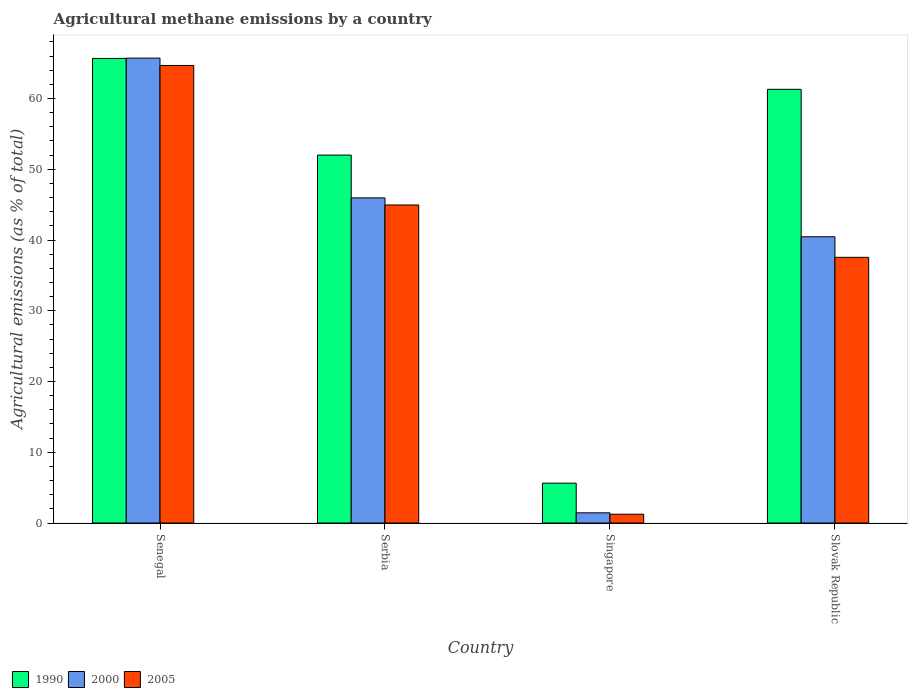How many different coloured bars are there?
Your answer should be compact. 3. Are the number of bars per tick equal to the number of legend labels?
Your response must be concise. Yes. Are the number of bars on each tick of the X-axis equal?
Your answer should be compact. Yes. What is the label of the 3rd group of bars from the left?
Give a very brief answer. Singapore. What is the amount of agricultural methane emitted in 2005 in Slovak Republic?
Give a very brief answer. 37.55. Across all countries, what is the maximum amount of agricultural methane emitted in 2000?
Offer a very short reply. 65.71. Across all countries, what is the minimum amount of agricultural methane emitted in 2000?
Keep it short and to the point. 1.44. In which country was the amount of agricultural methane emitted in 2005 maximum?
Your answer should be compact. Senegal. In which country was the amount of agricultural methane emitted in 2000 minimum?
Make the answer very short. Singapore. What is the total amount of agricultural methane emitted in 2000 in the graph?
Give a very brief answer. 153.56. What is the difference between the amount of agricultural methane emitted in 2005 in Serbia and that in Singapore?
Keep it short and to the point. 43.7. What is the difference between the amount of agricultural methane emitted in 2005 in Senegal and the amount of agricultural methane emitted in 2000 in Slovak Republic?
Ensure brevity in your answer.  24.21. What is the average amount of agricultural methane emitted in 2005 per country?
Your answer should be very brief. 37.1. What is the difference between the amount of agricultural methane emitted of/in 2005 and amount of agricultural methane emitted of/in 2000 in Singapore?
Give a very brief answer. -0.2. What is the ratio of the amount of agricultural methane emitted in 2000 in Serbia to that in Singapore?
Your answer should be compact. 31.84. What is the difference between the highest and the second highest amount of agricultural methane emitted in 1990?
Keep it short and to the point. 13.66. What is the difference between the highest and the lowest amount of agricultural methane emitted in 2000?
Your response must be concise. 64.26. Is the sum of the amount of agricultural methane emitted in 2005 in Senegal and Slovak Republic greater than the maximum amount of agricultural methane emitted in 1990 across all countries?
Make the answer very short. Yes. What does the 2nd bar from the right in Senegal represents?
Your answer should be compact. 2000. How many countries are there in the graph?
Make the answer very short. 4. Does the graph contain any zero values?
Provide a succinct answer. No. Does the graph contain grids?
Ensure brevity in your answer.  No. How are the legend labels stacked?
Ensure brevity in your answer.  Horizontal. What is the title of the graph?
Offer a very short reply. Agricultural methane emissions by a country. Does "1968" appear as one of the legend labels in the graph?
Give a very brief answer. No. What is the label or title of the X-axis?
Ensure brevity in your answer.  Country. What is the label or title of the Y-axis?
Offer a terse response. Agricultural emissions (as % of total). What is the Agricultural emissions (as % of total) in 1990 in Senegal?
Provide a short and direct response. 65.66. What is the Agricultural emissions (as % of total) of 2000 in Senegal?
Your answer should be compact. 65.71. What is the Agricultural emissions (as % of total) in 2005 in Senegal?
Provide a short and direct response. 64.67. What is the Agricultural emissions (as % of total) in 1990 in Serbia?
Keep it short and to the point. 52. What is the Agricultural emissions (as % of total) of 2000 in Serbia?
Keep it short and to the point. 45.95. What is the Agricultural emissions (as % of total) of 2005 in Serbia?
Your answer should be compact. 44.95. What is the Agricultural emissions (as % of total) of 1990 in Singapore?
Provide a short and direct response. 5.63. What is the Agricultural emissions (as % of total) in 2000 in Singapore?
Offer a terse response. 1.44. What is the Agricultural emissions (as % of total) of 2005 in Singapore?
Your answer should be very brief. 1.25. What is the Agricultural emissions (as % of total) in 1990 in Slovak Republic?
Offer a terse response. 61.3. What is the Agricultural emissions (as % of total) of 2000 in Slovak Republic?
Your response must be concise. 40.46. What is the Agricultural emissions (as % of total) in 2005 in Slovak Republic?
Provide a succinct answer. 37.55. Across all countries, what is the maximum Agricultural emissions (as % of total) in 1990?
Ensure brevity in your answer.  65.66. Across all countries, what is the maximum Agricultural emissions (as % of total) of 2000?
Provide a succinct answer. 65.71. Across all countries, what is the maximum Agricultural emissions (as % of total) in 2005?
Your answer should be very brief. 64.67. Across all countries, what is the minimum Agricultural emissions (as % of total) of 1990?
Your answer should be compact. 5.63. Across all countries, what is the minimum Agricultural emissions (as % of total) in 2000?
Ensure brevity in your answer.  1.44. Across all countries, what is the minimum Agricultural emissions (as % of total) of 2005?
Provide a succinct answer. 1.25. What is the total Agricultural emissions (as % of total) of 1990 in the graph?
Give a very brief answer. 184.6. What is the total Agricultural emissions (as % of total) in 2000 in the graph?
Give a very brief answer. 153.56. What is the total Agricultural emissions (as % of total) of 2005 in the graph?
Your answer should be compact. 148.42. What is the difference between the Agricultural emissions (as % of total) of 1990 in Senegal and that in Serbia?
Your answer should be compact. 13.66. What is the difference between the Agricultural emissions (as % of total) in 2000 in Senegal and that in Serbia?
Offer a very short reply. 19.75. What is the difference between the Agricultural emissions (as % of total) of 2005 in Senegal and that in Serbia?
Make the answer very short. 19.72. What is the difference between the Agricultural emissions (as % of total) of 1990 in Senegal and that in Singapore?
Offer a terse response. 60.03. What is the difference between the Agricultural emissions (as % of total) of 2000 in Senegal and that in Singapore?
Your response must be concise. 64.26. What is the difference between the Agricultural emissions (as % of total) in 2005 in Senegal and that in Singapore?
Provide a succinct answer. 63.42. What is the difference between the Agricultural emissions (as % of total) in 1990 in Senegal and that in Slovak Republic?
Ensure brevity in your answer.  4.37. What is the difference between the Agricultural emissions (as % of total) in 2000 in Senegal and that in Slovak Republic?
Ensure brevity in your answer.  25.25. What is the difference between the Agricultural emissions (as % of total) in 2005 in Senegal and that in Slovak Republic?
Your response must be concise. 27.12. What is the difference between the Agricultural emissions (as % of total) in 1990 in Serbia and that in Singapore?
Give a very brief answer. 46.37. What is the difference between the Agricultural emissions (as % of total) of 2000 in Serbia and that in Singapore?
Provide a short and direct response. 44.51. What is the difference between the Agricultural emissions (as % of total) in 2005 in Serbia and that in Singapore?
Your answer should be compact. 43.7. What is the difference between the Agricultural emissions (as % of total) in 1990 in Serbia and that in Slovak Republic?
Your answer should be compact. -9.3. What is the difference between the Agricultural emissions (as % of total) of 2000 in Serbia and that in Slovak Republic?
Keep it short and to the point. 5.49. What is the difference between the Agricultural emissions (as % of total) in 2005 in Serbia and that in Slovak Republic?
Provide a short and direct response. 7.4. What is the difference between the Agricultural emissions (as % of total) in 1990 in Singapore and that in Slovak Republic?
Ensure brevity in your answer.  -55.66. What is the difference between the Agricultural emissions (as % of total) of 2000 in Singapore and that in Slovak Republic?
Your answer should be compact. -39.01. What is the difference between the Agricultural emissions (as % of total) of 2005 in Singapore and that in Slovak Republic?
Offer a terse response. -36.3. What is the difference between the Agricultural emissions (as % of total) of 1990 in Senegal and the Agricultural emissions (as % of total) of 2000 in Serbia?
Your response must be concise. 19.71. What is the difference between the Agricultural emissions (as % of total) of 1990 in Senegal and the Agricultural emissions (as % of total) of 2005 in Serbia?
Provide a succinct answer. 20.71. What is the difference between the Agricultural emissions (as % of total) of 2000 in Senegal and the Agricultural emissions (as % of total) of 2005 in Serbia?
Make the answer very short. 20.76. What is the difference between the Agricultural emissions (as % of total) in 1990 in Senegal and the Agricultural emissions (as % of total) in 2000 in Singapore?
Your response must be concise. 64.22. What is the difference between the Agricultural emissions (as % of total) of 1990 in Senegal and the Agricultural emissions (as % of total) of 2005 in Singapore?
Keep it short and to the point. 64.41. What is the difference between the Agricultural emissions (as % of total) in 2000 in Senegal and the Agricultural emissions (as % of total) in 2005 in Singapore?
Ensure brevity in your answer.  64.46. What is the difference between the Agricultural emissions (as % of total) of 1990 in Senegal and the Agricultural emissions (as % of total) of 2000 in Slovak Republic?
Offer a terse response. 25.2. What is the difference between the Agricultural emissions (as % of total) in 1990 in Senegal and the Agricultural emissions (as % of total) in 2005 in Slovak Republic?
Make the answer very short. 28.11. What is the difference between the Agricultural emissions (as % of total) in 2000 in Senegal and the Agricultural emissions (as % of total) in 2005 in Slovak Republic?
Make the answer very short. 28.15. What is the difference between the Agricultural emissions (as % of total) of 1990 in Serbia and the Agricultural emissions (as % of total) of 2000 in Singapore?
Offer a very short reply. 50.56. What is the difference between the Agricultural emissions (as % of total) of 1990 in Serbia and the Agricultural emissions (as % of total) of 2005 in Singapore?
Offer a very short reply. 50.75. What is the difference between the Agricultural emissions (as % of total) of 2000 in Serbia and the Agricultural emissions (as % of total) of 2005 in Singapore?
Provide a succinct answer. 44.71. What is the difference between the Agricultural emissions (as % of total) of 1990 in Serbia and the Agricultural emissions (as % of total) of 2000 in Slovak Republic?
Keep it short and to the point. 11.54. What is the difference between the Agricultural emissions (as % of total) in 1990 in Serbia and the Agricultural emissions (as % of total) in 2005 in Slovak Republic?
Make the answer very short. 14.45. What is the difference between the Agricultural emissions (as % of total) of 2000 in Serbia and the Agricultural emissions (as % of total) of 2005 in Slovak Republic?
Offer a very short reply. 8.4. What is the difference between the Agricultural emissions (as % of total) of 1990 in Singapore and the Agricultural emissions (as % of total) of 2000 in Slovak Republic?
Give a very brief answer. -34.82. What is the difference between the Agricultural emissions (as % of total) in 1990 in Singapore and the Agricultural emissions (as % of total) in 2005 in Slovak Republic?
Ensure brevity in your answer.  -31.92. What is the difference between the Agricultural emissions (as % of total) in 2000 in Singapore and the Agricultural emissions (as % of total) in 2005 in Slovak Republic?
Provide a succinct answer. -36.11. What is the average Agricultural emissions (as % of total) of 1990 per country?
Your response must be concise. 46.15. What is the average Agricultural emissions (as % of total) in 2000 per country?
Ensure brevity in your answer.  38.39. What is the average Agricultural emissions (as % of total) in 2005 per country?
Offer a very short reply. 37.1. What is the difference between the Agricultural emissions (as % of total) in 1990 and Agricultural emissions (as % of total) in 2000 in Senegal?
Make the answer very short. -0.04. What is the difference between the Agricultural emissions (as % of total) in 2000 and Agricultural emissions (as % of total) in 2005 in Senegal?
Ensure brevity in your answer.  1.04. What is the difference between the Agricultural emissions (as % of total) of 1990 and Agricultural emissions (as % of total) of 2000 in Serbia?
Offer a very short reply. 6.05. What is the difference between the Agricultural emissions (as % of total) of 1990 and Agricultural emissions (as % of total) of 2005 in Serbia?
Your response must be concise. 7.05. What is the difference between the Agricultural emissions (as % of total) of 2000 and Agricultural emissions (as % of total) of 2005 in Serbia?
Your answer should be compact. 1. What is the difference between the Agricultural emissions (as % of total) of 1990 and Agricultural emissions (as % of total) of 2000 in Singapore?
Your answer should be compact. 4.19. What is the difference between the Agricultural emissions (as % of total) of 1990 and Agricultural emissions (as % of total) of 2005 in Singapore?
Your response must be concise. 4.39. What is the difference between the Agricultural emissions (as % of total) of 2000 and Agricultural emissions (as % of total) of 2005 in Singapore?
Provide a succinct answer. 0.2. What is the difference between the Agricultural emissions (as % of total) of 1990 and Agricultural emissions (as % of total) of 2000 in Slovak Republic?
Offer a terse response. 20.84. What is the difference between the Agricultural emissions (as % of total) in 1990 and Agricultural emissions (as % of total) in 2005 in Slovak Republic?
Offer a very short reply. 23.75. What is the difference between the Agricultural emissions (as % of total) in 2000 and Agricultural emissions (as % of total) in 2005 in Slovak Republic?
Provide a succinct answer. 2.91. What is the ratio of the Agricultural emissions (as % of total) of 1990 in Senegal to that in Serbia?
Make the answer very short. 1.26. What is the ratio of the Agricultural emissions (as % of total) of 2000 in Senegal to that in Serbia?
Your answer should be compact. 1.43. What is the ratio of the Agricultural emissions (as % of total) of 2005 in Senegal to that in Serbia?
Offer a terse response. 1.44. What is the ratio of the Agricultural emissions (as % of total) in 1990 in Senegal to that in Singapore?
Make the answer very short. 11.65. What is the ratio of the Agricultural emissions (as % of total) of 2000 in Senegal to that in Singapore?
Your answer should be very brief. 45.53. What is the ratio of the Agricultural emissions (as % of total) in 2005 in Senegal to that in Singapore?
Provide a succinct answer. 51.84. What is the ratio of the Agricultural emissions (as % of total) of 1990 in Senegal to that in Slovak Republic?
Provide a succinct answer. 1.07. What is the ratio of the Agricultural emissions (as % of total) of 2000 in Senegal to that in Slovak Republic?
Your answer should be compact. 1.62. What is the ratio of the Agricultural emissions (as % of total) of 2005 in Senegal to that in Slovak Republic?
Give a very brief answer. 1.72. What is the ratio of the Agricultural emissions (as % of total) in 1990 in Serbia to that in Singapore?
Offer a terse response. 9.23. What is the ratio of the Agricultural emissions (as % of total) of 2000 in Serbia to that in Singapore?
Ensure brevity in your answer.  31.84. What is the ratio of the Agricultural emissions (as % of total) of 2005 in Serbia to that in Singapore?
Your response must be concise. 36.04. What is the ratio of the Agricultural emissions (as % of total) of 1990 in Serbia to that in Slovak Republic?
Ensure brevity in your answer.  0.85. What is the ratio of the Agricultural emissions (as % of total) of 2000 in Serbia to that in Slovak Republic?
Provide a short and direct response. 1.14. What is the ratio of the Agricultural emissions (as % of total) of 2005 in Serbia to that in Slovak Republic?
Make the answer very short. 1.2. What is the ratio of the Agricultural emissions (as % of total) in 1990 in Singapore to that in Slovak Republic?
Keep it short and to the point. 0.09. What is the ratio of the Agricultural emissions (as % of total) of 2000 in Singapore to that in Slovak Republic?
Your answer should be compact. 0.04. What is the ratio of the Agricultural emissions (as % of total) in 2005 in Singapore to that in Slovak Republic?
Offer a terse response. 0.03. What is the difference between the highest and the second highest Agricultural emissions (as % of total) of 1990?
Ensure brevity in your answer.  4.37. What is the difference between the highest and the second highest Agricultural emissions (as % of total) of 2000?
Give a very brief answer. 19.75. What is the difference between the highest and the second highest Agricultural emissions (as % of total) in 2005?
Ensure brevity in your answer.  19.72. What is the difference between the highest and the lowest Agricultural emissions (as % of total) in 1990?
Keep it short and to the point. 60.03. What is the difference between the highest and the lowest Agricultural emissions (as % of total) in 2000?
Keep it short and to the point. 64.26. What is the difference between the highest and the lowest Agricultural emissions (as % of total) in 2005?
Your response must be concise. 63.42. 